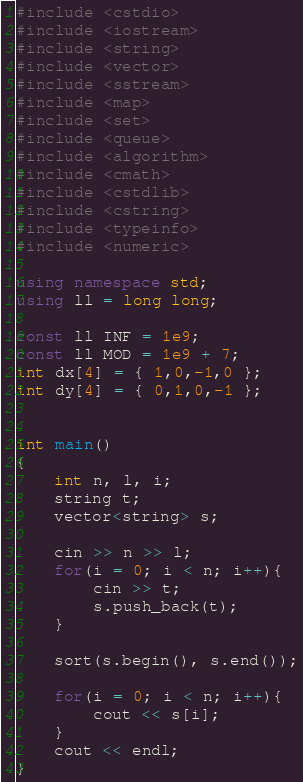Convert code to text. <code><loc_0><loc_0><loc_500><loc_500><_C++_>#include <cstdio>
#include <iostream> 
#include <string>
#include <vector>
#include <sstream>
#include <map>
#include <set>
#include <queue>
#include <algorithm>
#include <cmath>
#include <cstdlib>
#include <cstring>
#include <typeinfo>
#include <numeric>
 
using namespace std;
using ll = long long;
 
const ll INF = 1e9;
const ll MOD = 1e9 + 7;
int dx[4] = { 1,0,-1,0 };
int dy[4] = { 0,1,0,-1 };


int main()
{
    int n, l, i;
    string t;
    vector<string> s;

    cin >> n >> l;
    for(i = 0; i < n; i++){
        cin >> t;
        s.push_back(t);
    }

    sort(s.begin(), s.end());

    for(i = 0; i < n; i++){
        cout << s[i];
    }
    cout << endl;
}</code> 